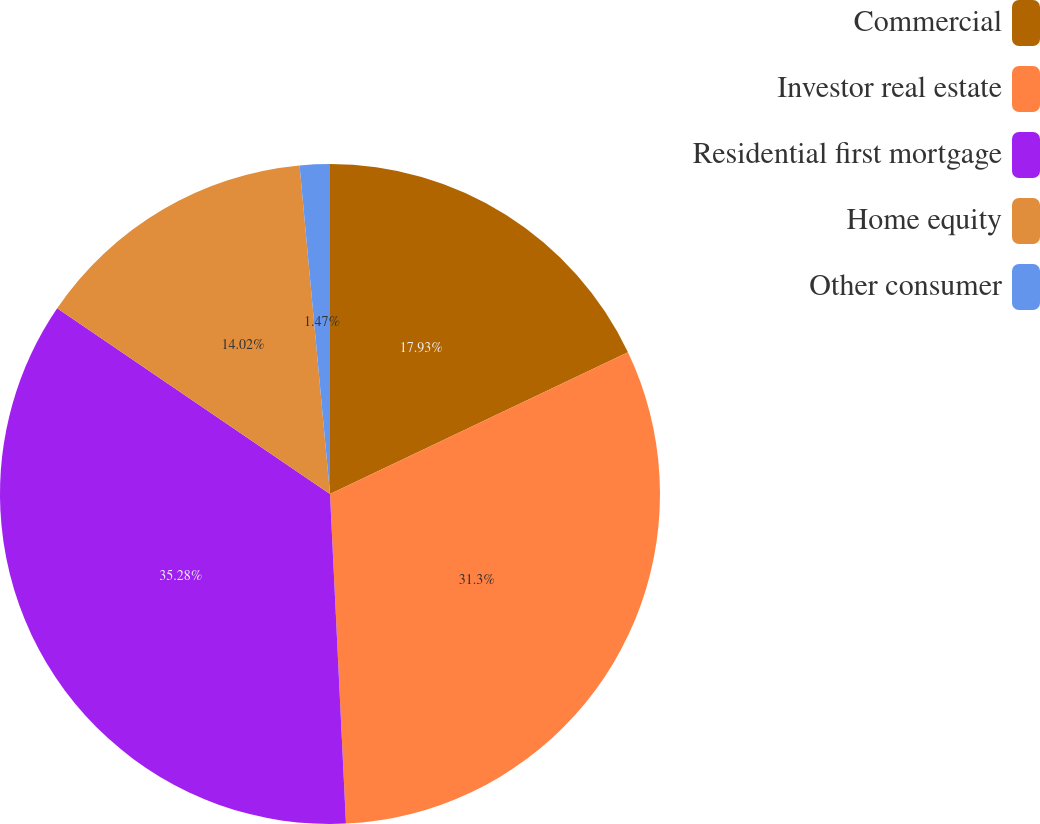Convert chart. <chart><loc_0><loc_0><loc_500><loc_500><pie_chart><fcel>Commercial<fcel>Investor real estate<fcel>Residential first mortgage<fcel>Home equity<fcel>Other consumer<nl><fcel>17.93%<fcel>31.3%<fcel>35.28%<fcel>14.02%<fcel>1.47%<nl></chart> 